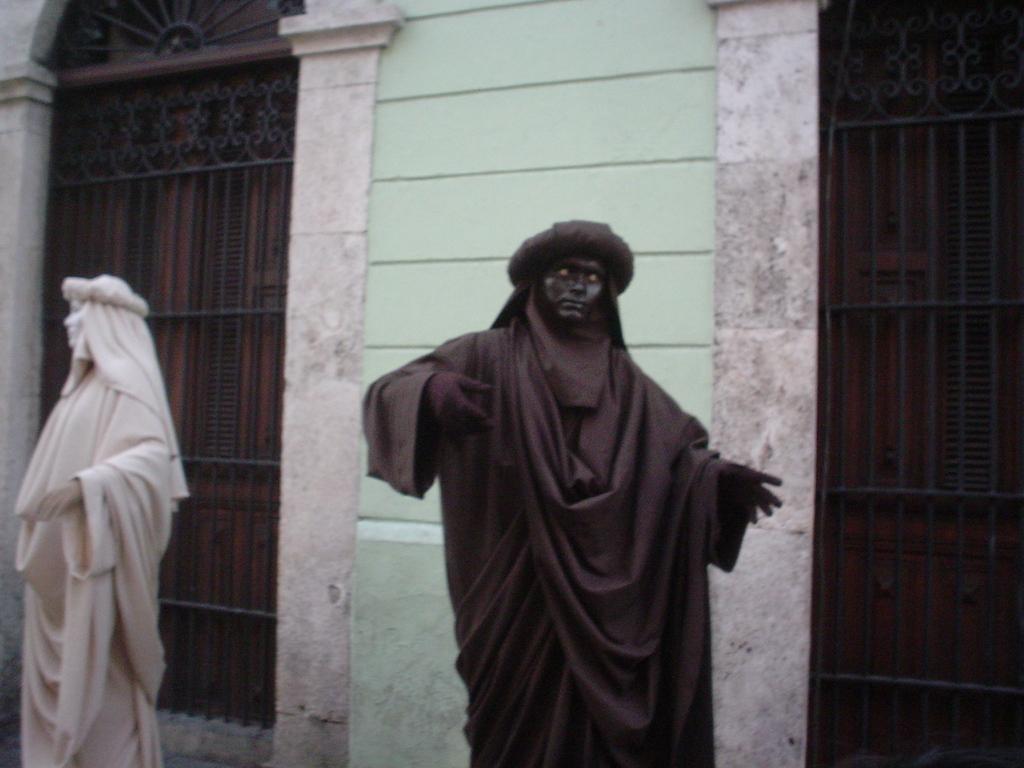In one or two sentences, can you explain what this image depicts? In this picture we can see few statues, in the background we can find a building and few metal rods. 